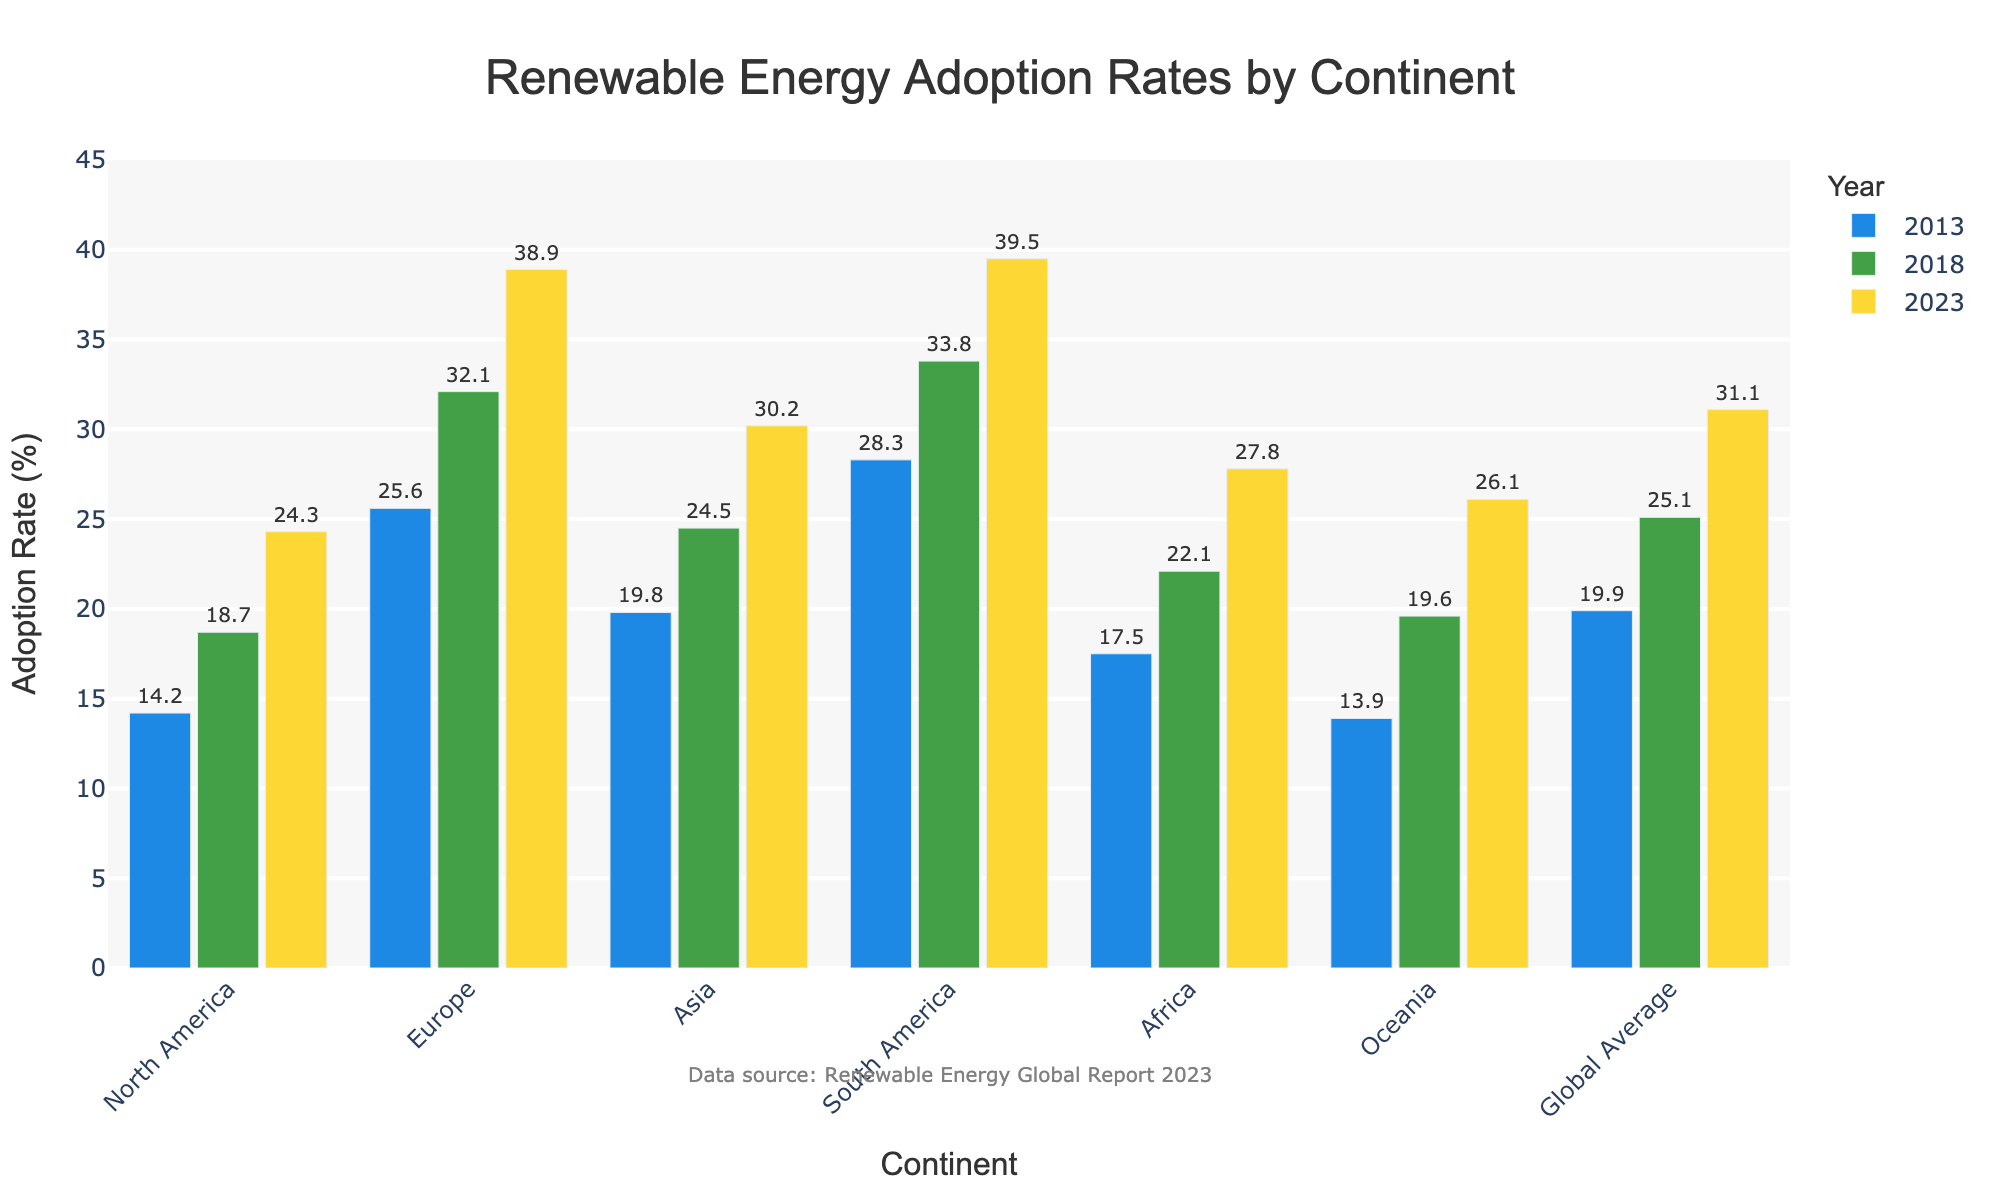Which continent had the highest renewable energy adoption rate in 2023? Visually examine the heights of the bars for each continent in 2023; the highest bar represents the continent with the highest adoption rate. South America has the tallest bar in 2023.
Answer: South America How much did the renewable energy adoption rate increase in Oceania from 2013 to 2023? Subtract Oceania's 2013 adoption rate from its 2023 adoption rate: 26.1 - 13.9 = 12.2%.
Answer: 12.2% Which continent showed the largest increase in renewable energy adoption rate between 2013 and 2023? Calculate the difference in adoption rates for each continent and compare: 
- North America: 24.3 - 14.2 = 10.1
- Europe: 38.9 - 25.6 = 13.3
- Asia: 30.2 - 19.8 = 10.4
- South America: 39.5 - 28.3 = 11.2
- Africa: 27.8 - 17.5 = 10.3
- Oceania: 26.1 - 13.9 = 12.2 
Europe has the largest increase of 13.3%.
Answer: Europe What is the global average renewable energy adoption rate in 2018? Look at the bar for 'Global Average' in 2018 and read the value. The height of the bar shows the rate is 25.1%.
Answer: 25.1% Compare the renewable energy adoption rates of Africa and North America in 2023. Which one is higher and by how much? Look at the heights of the bars for Africa and North America in 2023:
- Africa's rate: 27.8%
- North America's rate: 24.3%
Subtract North America's rate from Africa's rate: 27.8 - 24.3 = 3.5%. Africa's rate is 3.5% higher.
Answer: Africa by 3.5% What is the difference in renewable energy adoption rates between the continents with the highest and lowest rates in 2018? Identify the highest and lowest rates from the 2018 bars:
- Highest: South America at 33.8%
- Lowest: North America at 18.7%
Subtract the lowest from the highest: 33.8 - 18.7 = 15.1%.
Answer: 15.1% What was the average renewable energy adoption rate of Europe across the three years provided? Calculate the sum of Europe's rates for 2013, 2018, and 2023 and divide by 3: 
(25.6 + 32.1 + 38.9) / 3 ≈ 32.2%.
Answer: 32.2% Which two continents had very similar renewable energy adoption rates in 2023? Compare the heights of the bars in 2023 visually to find similar values:
- Asia: 30.2%
- Oceania: 26.1%
The closest pair visually is Asia and Oceania, but the difference (4.1%) doesn't match "very similar". Thus, no pair is ideally very similar.
Answer: None 